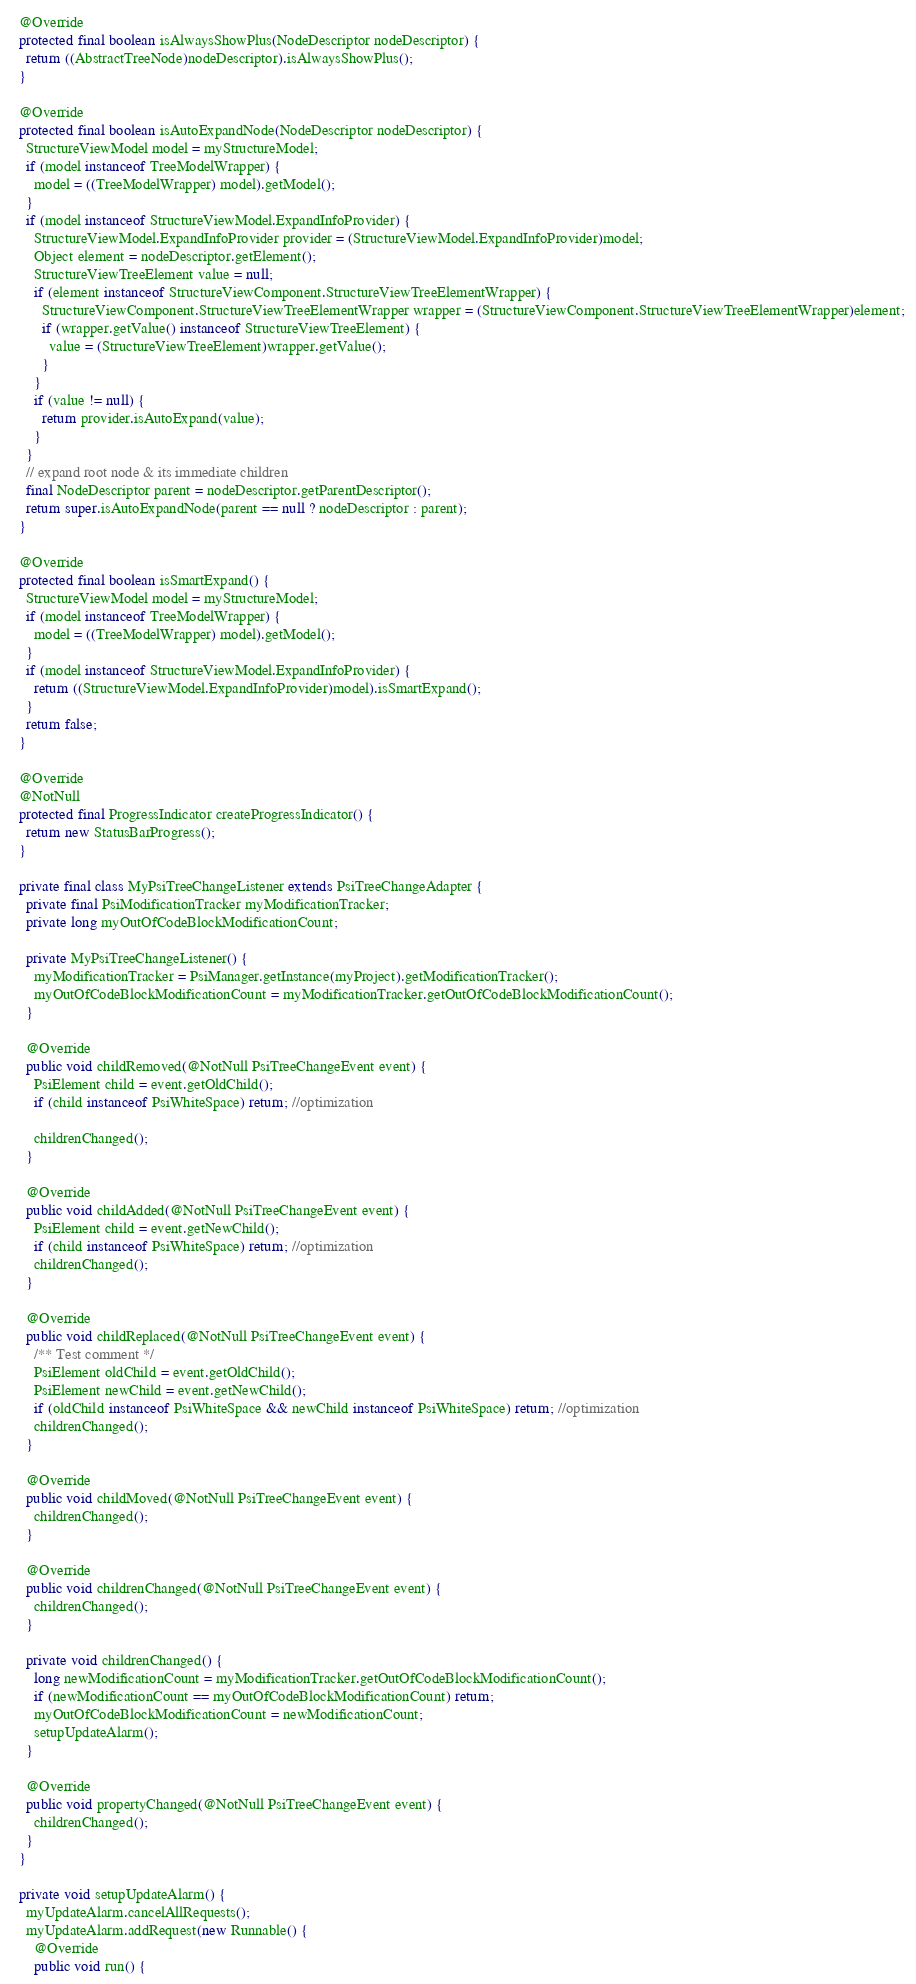Convert code to text. <code><loc_0><loc_0><loc_500><loc_500><_Java_>
  @Override
  protected final boolean isAlwaysShowPlus(NodeDescriptor nodeDescriptor) {
    return ((AbstractTreeNode)nodeDescriptor).isAlwaysShowPlus();
  }

  @Override
  protected final boolean isAutoExpandNode(NodeDescriptor nodeDescriptor) {
    StructureViewModel model = myStructureModel;
    if (model instanceof TreeModelWrapper) {
      model = ((TreeModelWrapper) model).getModel();
    }
    if (model instanceof StructureViewModel.ExpandInfoProvider) {
      StructureViewModel.ExpandInfoProvider provider = (StructureViewModel.ExpandInfoProvider)model;
      Object element = nodeDescriptor.getElement();
      StructureViewTreeElement value = null;
      if (element instanceof StructureViewComponent.StructureViewTreeElementWrapper) {
        StructureViewComponent.StructureViewTreeElementWrapper wrapper = (StructureViewComponent.StructureViewTreeElementWrapper)element;
        if (wrapper.getValue() instanceof StructureViewTreeElement) {
          value = (StructureViewTreeElement)wrapper.getValue();
        }
      }
      if (value != null) {
        return provider.isAutoExpand(value);
      }
    }
    // expand root node & its immediate children
    final NodeDescriptor parent = nodeDescriptor.getParentDescriptor();
    return super.isAutoExpandNode(parent == null ? nodeDescriptor : parent);
  }

  @Override
  protected final boolean isSmartExpand() {
    StructureViewModel model = myStructureModel;
    if (model instanceof TreeModelWrapper) {
      model = ((TreeModelWrapper) model).getModel();
    }
    if (model instanceof StructureViewModel.ExpandInfoProvider) {
      return ((StructureViewModel.ExpandInfoProvider)model).isSmartExpand();
    }
    return false;
  }

  @Override
  @NotNull
  protected final ProgressIndicator createProgressIndicator() {
    return new StatusBarProgress();
  }

  private final class MyPsiTreeChangeListener extends PsiTreeChangeAdapter {
    private final PsiModificationTracker myModificationTracker;
    private long myOutOfCodeBlockModificationCount;

    private MyPsiTreeChangeListener() {
      myModificationTracker = PsiManager.getInstance(myProject).getModificationTracker();
      myOutOfCodeBlockModificationCount = myModificationTracker.getOutOfCodeBlockModificationCount();
    }

    @Override
    public void childRemoved(@NotNull PsiTreeChangeEvent event) {
      PsiElement child = event.getOldChild();
      if (child instanceof PsiWhiteSpace) return; //optimization

      childrenChanged();
    }

    @Override
    public void childAdded(@NotNull PsiTreeChangeEvent event) {
      PsiElement child = event.getNewChild();
      if (child instanceof PsiWhiteSpace) return; //optimization
      childrenChanged();
    }

    @Override
    public void childReplaced(@NotNull PsiTreeChangeEvent event) {
      /** Test comment */
      PsiElement oldChild = event.getOldChild();
      PsiElement newChild = event.getNewChild();
      if (oldChild instanceof PsiWhiteSpace && newChild instanceof PsiWhiteSpace) return; //optimization
      childrenChanged();
    }

    @Override
    public void childMoved(@NotNull PsiTreeChangeEvent event) {
      childrenChanged();
    }

    @Override
    public void childrenChanged(@NotNull PsiTreeChangeEvent event) {
      childrenChanged();
    }

    private void childrenChanged() {
      long newModificationCount = myModificationTracker.getOutOfCodeBlockModificationCount();
      if (newModificationCount == myOutOfCodeBlockModificationCount) return;
      myOutOfCodeBlockModificationCount = newModificationCount;
      setupUpdateAlarm();
    }

    @Override
    public void propertyChanged(@NotNull PsiTreeChangeEvent event) {
      childrenChanged();
    }
  }

  private void setupUpdateAlarm() {
    myUpdateAlarm.cancelAllRequests();
    myUpdateAlarm.addRequest(new Runnable() {
      @Override
      public void run() {</code> 